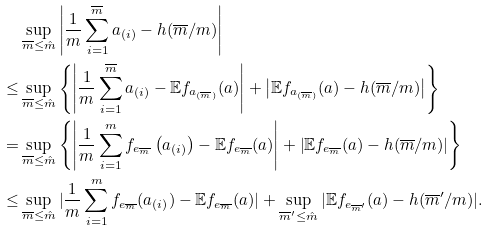Convert formula to latex. <formula><loc_0><loc_0><loc_500><loc_500>& \sup _ { \overline { m } \leq \hat { m } } \left | \frac { 1 } { m } \sum _ { i = 1 } ^ { \overline { m } } a _ { ( i ) } - h ( \overline { m } / m ) \right | \\ \leq & \sup _ { \overline { m } \leq \hat { m } } \left \{ \left | \frac { 1 } { m } \sum _ { i = 1 } ^ { \overline { m } } a _ { ( i ) } - \mathbb { E } f _ { a _ { ( \overline { m } ) } } ( a ) \right | + \left | \mathbb { E } f _ { a _ { ( \overline { m } ) } } ( a ) - h ( \overline { m } / m ) \right | \right \} \\ = & \sup _ { \overline { m } \leq \hat { m } } \left \{ \left | \frac { 1 } { m } \sum _ { i = 1 } ^ { m } f _ { e _ { \overline { m } } } \left ( a _ { ( i ) } \right ) - \mathbb { E } f _ { e _ { \overline { m } } } ( a ) \right | + \left | \mathbb { E } f _ { e _ { \overline { m } } } ( a ) - h ( \overline { m } / m ) \right | \right \} \\ \leq & \sup _ { \overline { m } \leq \hat { m } } | \frac { 1 } { m } \sum _ { i = 1 } ^ { m } f _ { e _ { \overline { m } } } ( a _ { ( i ) } ) - \mathbb { E } f _ { e _ { \overline { m } } } ( a ) | + \sup _ { \overline { m } ^ { \prime } \leq \hat { m } } | \mathbb { E } f _ { e _ { \overline { m } ^ { \prime } } } ( a ) - h ( \overline { m } ^ { \prime } / m ) | .</formula> 